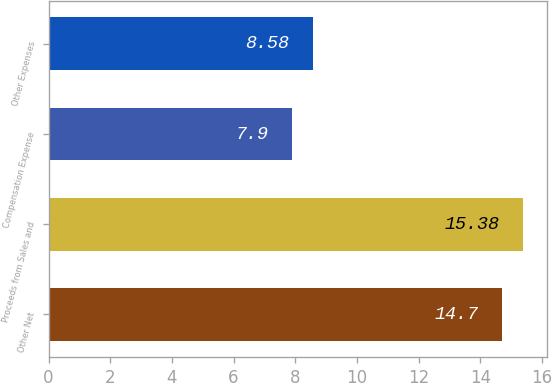<chart> <loc_0><loc_0><loc_500><loc_500><bar_chart><fcel>Other Net<fcel>Proceeds from Sales and<fcel>Compensation Expense<fcel>Other Expenses<nl><fcel>14.7<fcel>15.38<fcel>7.9<fcel>8.58<nl></chart> 